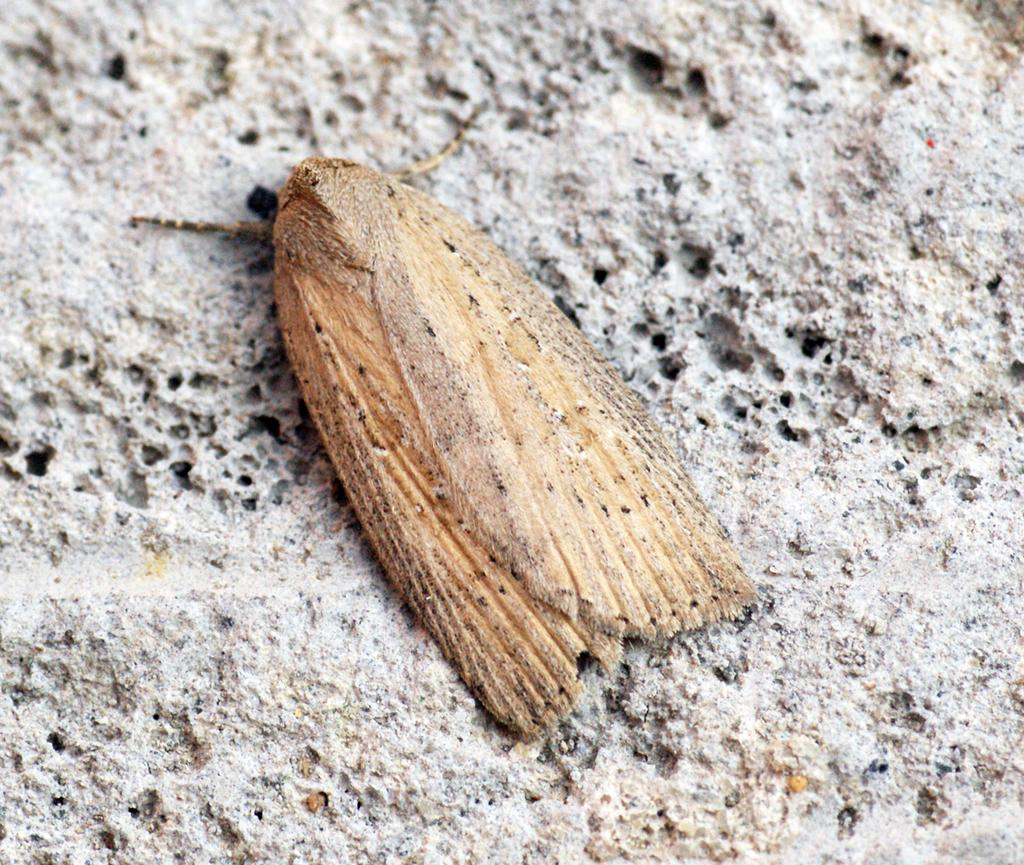What type of creature can be seen in the image? There is an insect in the image. What is the insect's location in the image? The insect is on a rock surface. What type of toys can be seen in the image? There are no toys present in the image. Is the insect in the image touching the rock surface? The image does not provide information about whether the insect is touching the rock surface or not. 